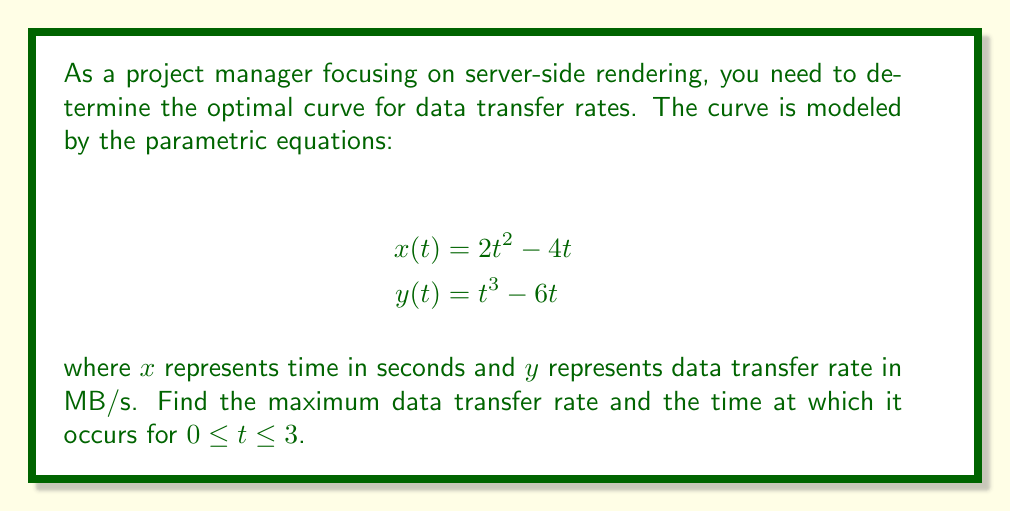Can you solve this math problem? To find the maximum data transfer rate and the corresponding time, we need to follow these steps:

1) First, we need to find the critical points of $y$ with respect to $t$. To do this, we differentiate $y$ with respect to $t$:

   $$\frac{dy}{dt} = 3t^2 - 6$$

2) Set this equal to zero and solve for $t$:

   $$3t^2 - 6 = 0$$
   $$3t^2 = 6$$
   $$t^2 = 2$$
   $$t = \pm\sqrt{2}$$

3) Since we're only considering $0 \leq t \leq 3$, we only need to consider $t = \sqrt{2}$.

4) To confirm this is a maximum, we can check the second derivative:

   $$\frac{d^2y}{dt^2} = 6t$$

   At $t = \sqrt{2}$, this is positive, confirming a local minimum for $y$. Since $y$ represents the negative of the data transfer rate, this corresponds to a maximum data transfer rate.

5) Now, we need to find the $x$ and $y$ coordinates at this point:

   $$x(\sqrt{2}) = 2(\sqrt{2})^2 - 4\sqrt{2} = 4 - 4\sqrt{2}$$
   $$y(\sqrt{2}) = (\sqrt{2})^3 - 6\sqrt{2} = 2\sqrt{2} - 6\sqrt{2} = -4\sqrt{2}$$

6) The $x$ coordinate represents the time, and the $y$ coordinate represents the negative of the data transfer rate. So, the maximum data transfer rate is $4\sqrt{2}$ MB/s, occurring at time $4 - 4\sqrt{2}$ seconds.
Answer: The maximum data transfer rate is $4\sqrt{2}$ MB/s, occurring at time $4 - 4\sqrt{2}$ seconds (approximately 1.34 seconds). 